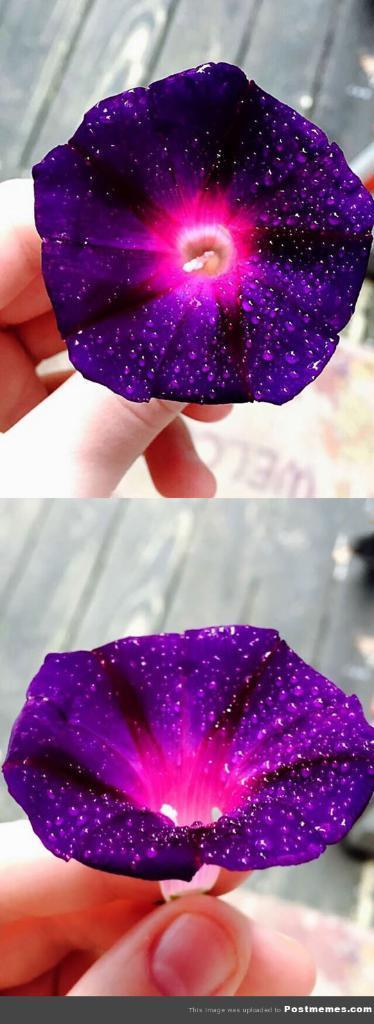How would you summarize this image in a sentence or two? In the image we can see a human hand and holding a flower. The flower is purple and pink in color. 